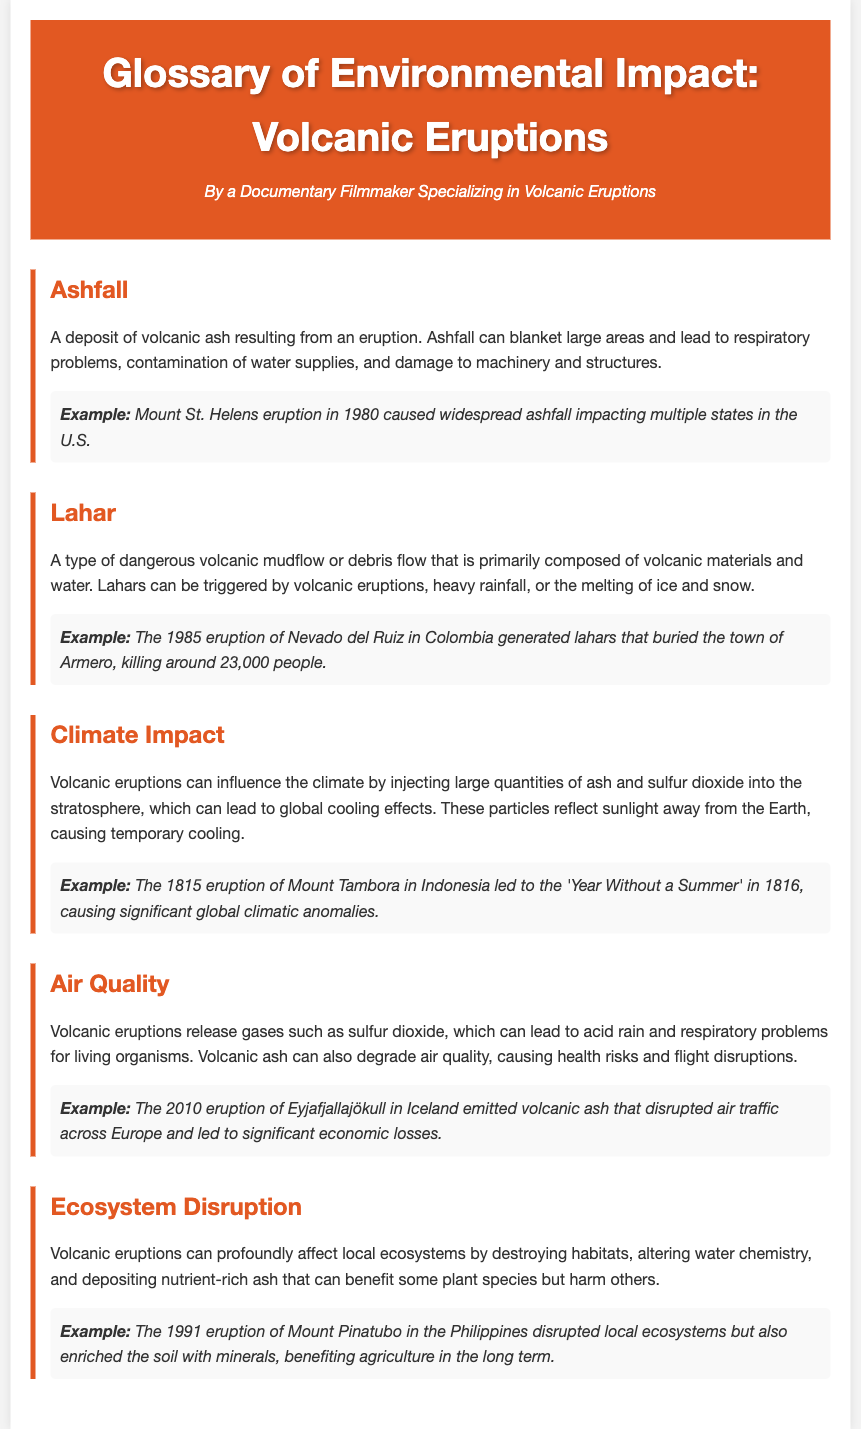what is ashfall? Ashfall is defined as a deposit of volcanic ash resulting from an eruption.
Answer: A deposit of volcanic ash what did the 1980 Mount St. Helens eruption cause? The 1980 Mount St. Helens eruption caused widespread ashfall impacting multiple states in the U.S.
Answer: Widespread ashfall what are lahars primarily composed of? Lahars are primarily composed of volcanic materials and water.
Answer: Volcanic materials and water which eruption led to the 'Year Without a Summer'? The 1815 eruption of Mount Tambora in Indonesia led to the 'Year Without a Summer'.
Answer: Mount Tambora what gas is released during volcanic eruptions that affects air quality? Volcanic eruptions release sulfur dioxide, which affects air quality.
Answer: Sulfur dioxide how did the 1991 eruption of Mount Pinatubo affect agriculture? The 1991 eruption of Mount Pinatubo enriched the soil with minerals, benefiting agriculture in the long term.
Answer: Enriched soil with minerals what natural disaster can lahars be triggered by? Lahars can be triggered by volcanic eruptions, heavy rainfall, or the melting of ice and snow.
Answer: Volcanic eruptions, heavy rainfall, or melting ice and snow what is the potential consequence of volcanic ash on health? Volcanic ash can cause respiratory problems for living organisms.
Answer: Respiratory problems what is the definition of ecosystem disruption? Ecosystem disruption is described as the profound effect on local ecosystems by destroying habitats and altering water chemistry.
Answer: Profound effect on local ecosystems 